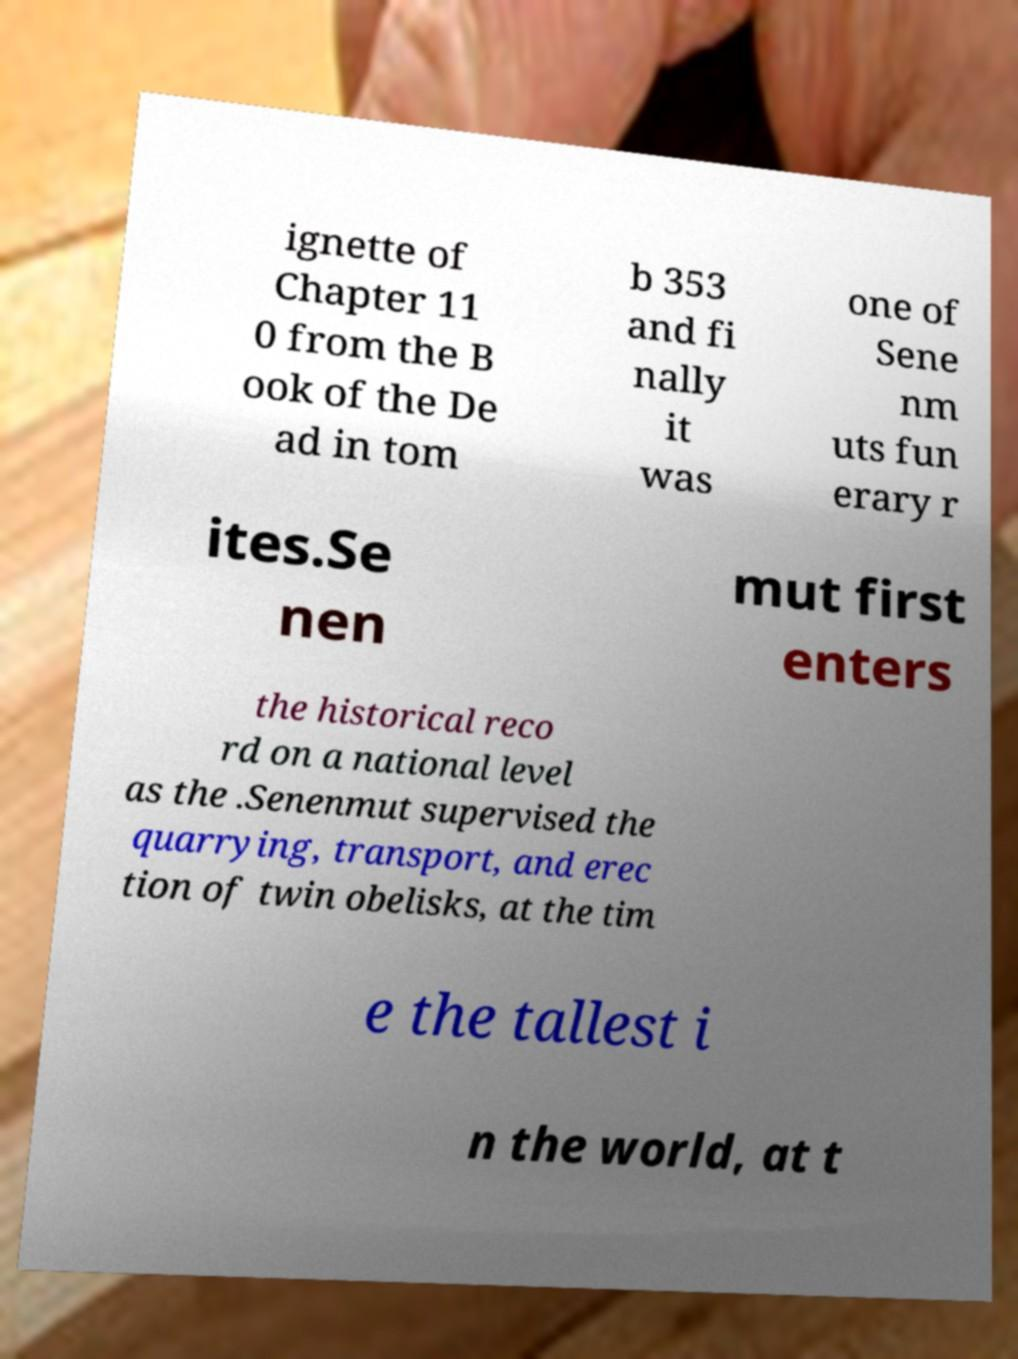There's text embedded in this image that I need extracted. Can you transcribe it verbatim? ignette of Chapter 11 0 from the B ook of the De ad in tom b 353 and fi nally it was one of Sene nm uts fun erary r ites.Se nen mut first enters the historical reco rd on a national level as the .Senenmut supervised the quarrying, transport, and erec tion of twin obelisks, at the tim e the tallest i n the world, at t 